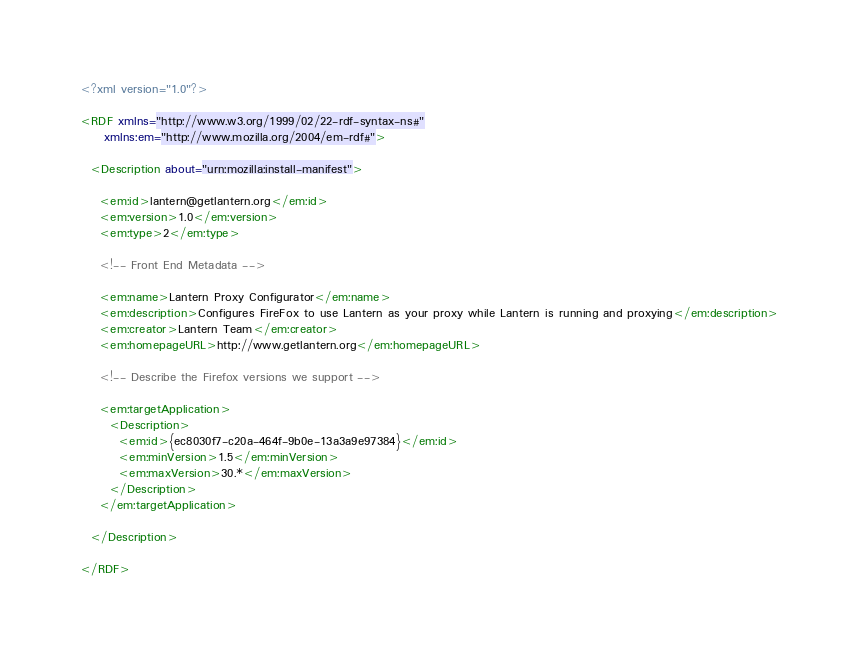<code> <loc_0><loc_0><loc_500><loc_500><_XML_><?xml version="1.0"?>

<RDF xmlns="http://www.w3.org/1999/02/22-rdf-syntax-ns#"
     xmlns:em="http://www.mozilla.org/2004/em-rdf#">

  <Description about="urn:mozilla:install-manifest">

    <em:id>lantern@getlantern.org</em:id>
    <em:version>1.0</em:version>
    <em:type>2</em:type>

    <!-- Front End Metadata -->

    <em:name>Lantern Proxy Configurator</em:name>
    <em:description>Configures FireFox to use Lantern as your proxy while Lantern is running and proxying</em:description>
    <em:creator>Lantern Team</em:creator>
    <em:homepageURL>http://www.getlantern.org</em:homepageURL>

    <!-- Describe the Firefox versions we support -->

    <em:targetApplication>
      <Description>
      	<em:id>{ec8030f7-c20a-464f-9b0e-13a3a9e97384}</em:id>
        <em:minVersion>1.5</em:minVersion>
        <em:maxVersion>30.*</em:maxVersion>
      </Description>
    </em:targetApplication>

  </Description>

</RDF>
</code> 